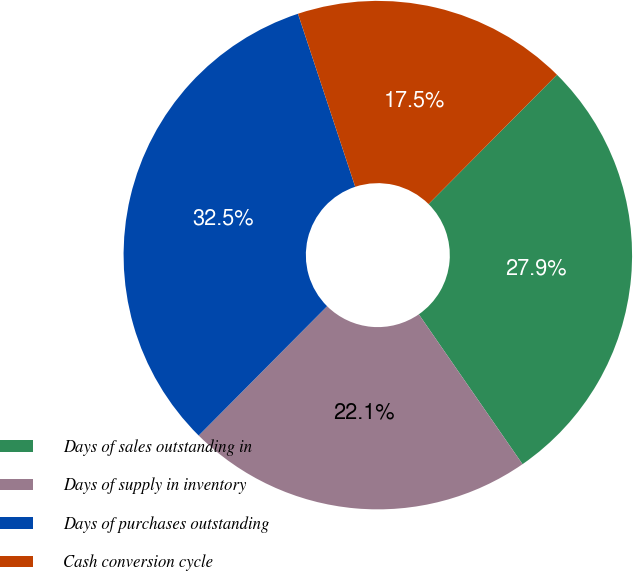<chart> <loc_0><loc_0><loc_500><loc_500><pie_chart><fcel>Days of sales outstanding in<fcel>Days of supply in inventory<fcel>Days of purchases outstanding<fcel>Cash conversion cycle<nl><fcel>27.92%<fcel>22.08%<fcel>32.47%<fcel>17.53%<nl></chart> 